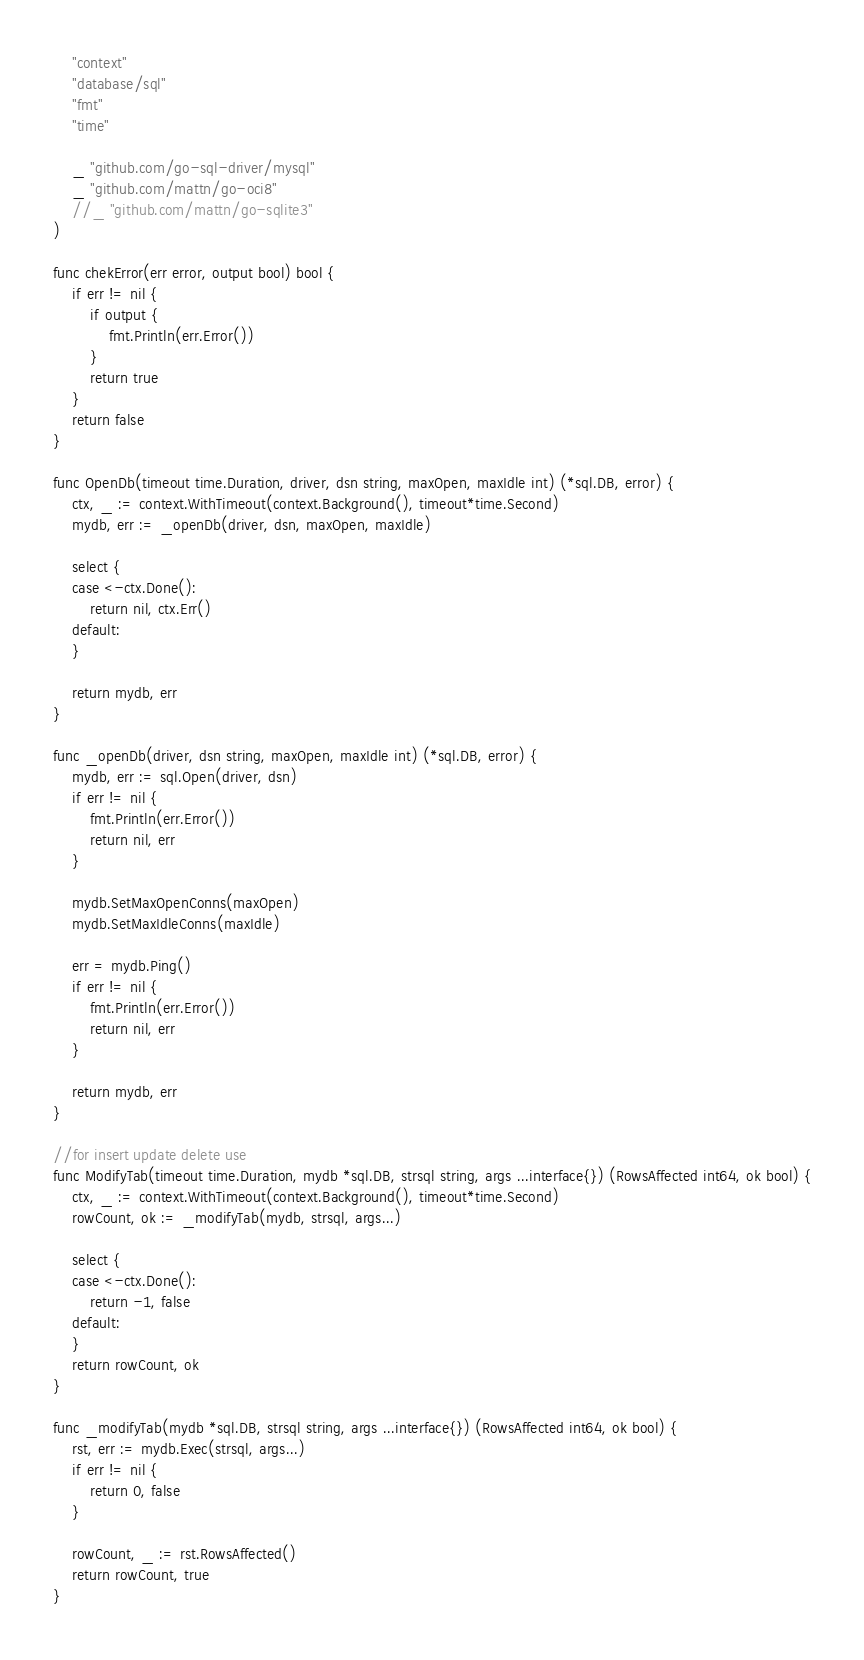Convert code to text. <code><loc_0><loc_0><loc_500><loc_500><_Go_>	"context"
	"database/sql"
	"fmt"
	"time"

	_ "github.com/go-sql-driver/mysql"
	_ "github.com/mattn/go-oci8"
	//_ "github.com/mattn/go-sqlite3"
)

func chekError(err error, output bool) bool {
	if err != nil {
		if output {
			fmt.Println(err.Error())
		}
		return true
	}
	return false
}

func OpenDb(timeout time.Duration, driver, dsn string, maxOpen, maxIdle int) (*sql.DB, error) {
	ctx, _ := context.WithTimeout(context.Background(), timeout*time.Second)
	mydb, err := _openDb(driver, dsn, maxOpen, maxIdle)

	select {
	case <-ctx.Done():
		return nil, ctx.Err()
	default:
	}

	return mydb, err
}

func _openDb(driver, dsn string, maxOpen, maxIdle int) (*sql.DB, error) {
	mydb, err := sql.Open(driver, dsn)
	if err != nil {
		fmt.Println(err.Error())
		return nil, err
	}

	mydb.SetMaxOpenConns(maxOpen)
	mydb.SetMaxIdleConns(maxIdle)

	err = mydb.Ping()
	if err != nil {
		fmt.Println(err.Error())
		return nil, err
	}

	return mydb, err
}

//for insert update delete use
func ModifyTab(timeout time.Duration, mydb *sql.DB, strsql string, args ...interface{}) (RowsAffected int64, ok bool) {
	ctx, _ := context.WithTimeout(context.Background(), timeout*time.Second)
	rowCount, ok := _modifyTab(mydb, strsql, args...)

	select {
	case <-ctx.Done():
		return -1, false
	default:
	}
	return rowCount, ok
}

func _modifyTab(mydb *sql.DB, strsql string, args ...interface{}) (RowsAffected int64, ok bool) {
	rst, err := mydb.Exec(strsql, args...)
	if err != nil {
		return 0, false
	}

	rowCount, _ := rst.RowsAffected()
	return rowCount, true
}
</code> 